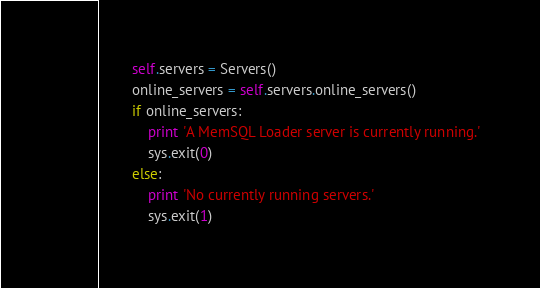Convert code to text. <code><loc_0><loc_0><loc_500><loc_500><_Python_>        self.servers = Servers()
        online_servers = self.servers.online_servers()
        if online_servers:
            print 'A MemSQL Loader server is currently running.'
            sys.exit(0)
        else:
            print 'No currently running servers.'
            sys.exit(1)
</code> 